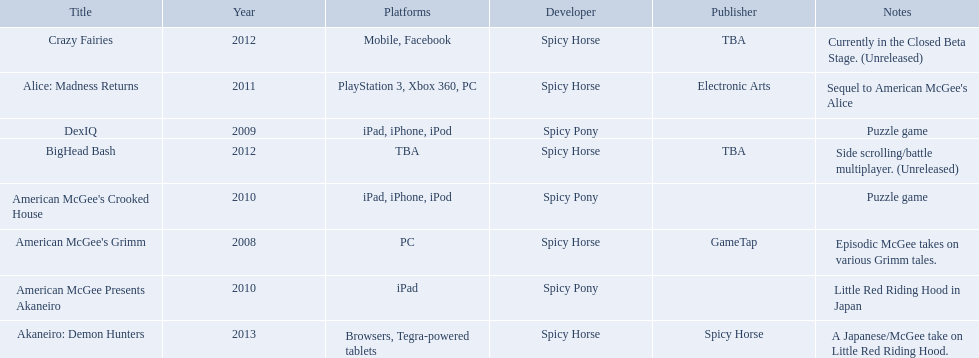What are all of the titles? American McGee's Grimm, DexIQ, American McGee Presents Akaneiro, American McGee's Crooked House, Alice: Madness Returns, BigHead Bash, Crazy Fairies, Akaneiro: Demon Hunters. Who published each title? GameTap, , , , Electronic Arts, TBA, TBA, Spicy Horse. Which game was published by electronics arts? Alice: Madness Returns. 